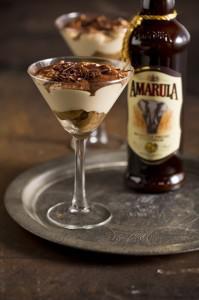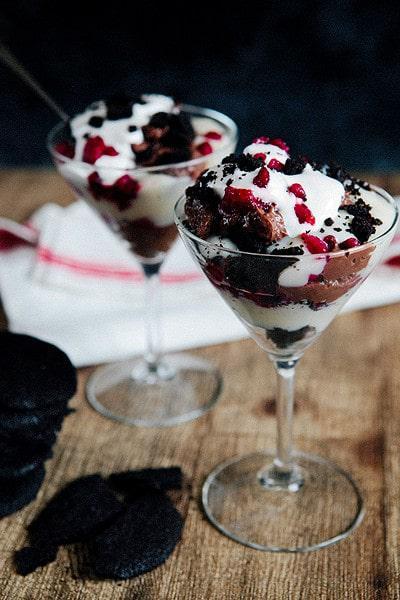The first image is the image on the left, the second image is the image on the right. Analyze the images presented: Is the assertion "There are exactly four layered desserts in cups." valid? Answer yes or no. Yes. 